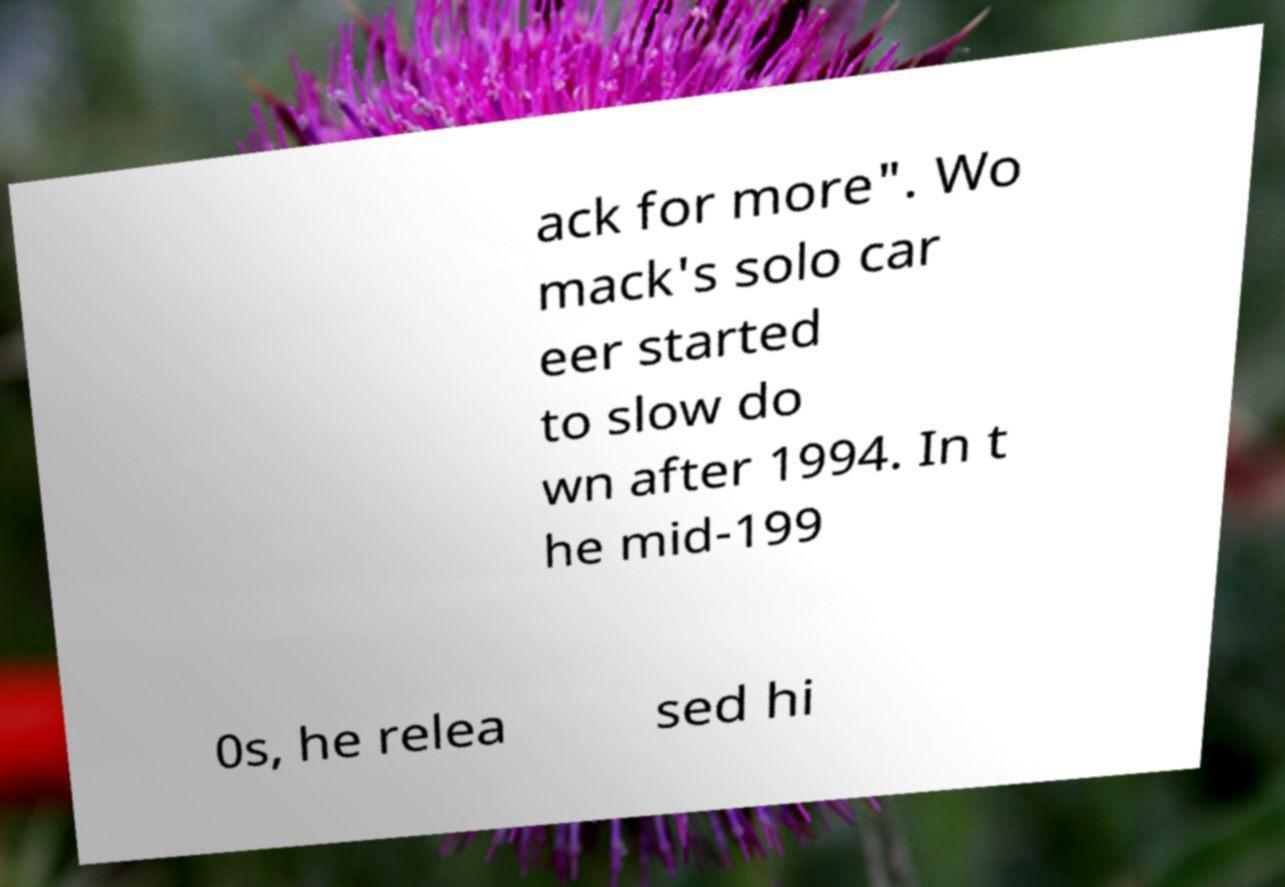Could you assist in decoding the text presented in this image and type it out clearly? ack for more". Wo mack's solo car eer started to slow do wn after 1994. In t he mid-199 0s, he relea sed hi 